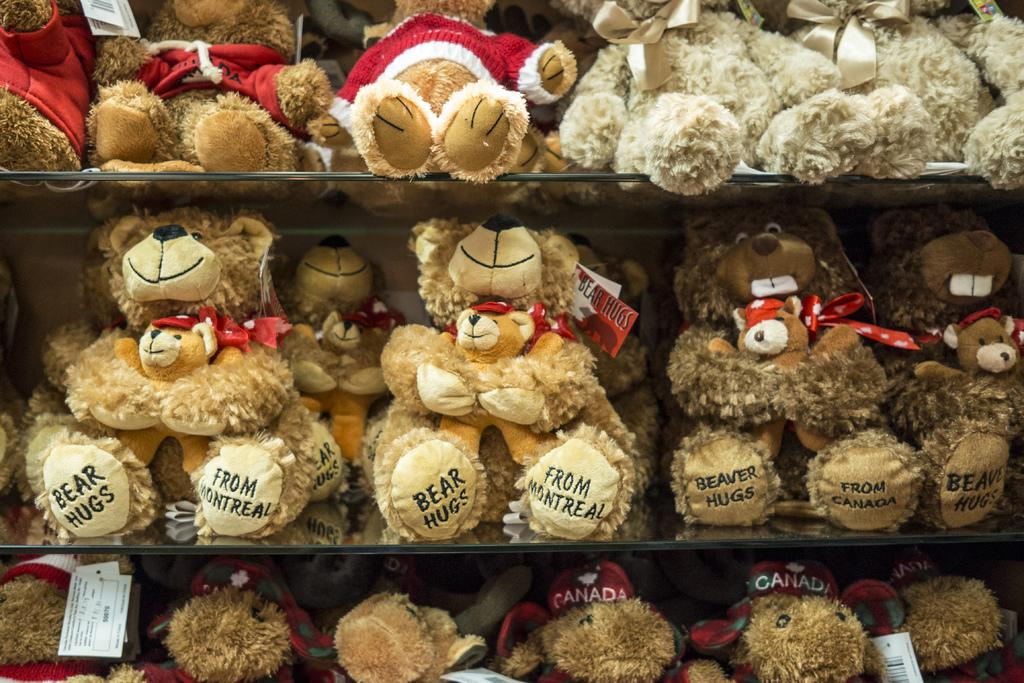How many racks are visible in the image? There are three racks in the image. What types of items can be seen on the racks? Each rack contains different types of teddy bears and dolls. Is there any additional information provided in the image? Yes, there is a tag in the bottom left corner of the image. What type of cheese is being served on the tray in the image? There is no tray or cheese present in the image; it features racks with teddy bears and dolls. Can you tell me the name of the hospital where the scene in the image takes place? The image does not depict a hospital or any medical setting; it shows racks with teddy bears and dolls. 